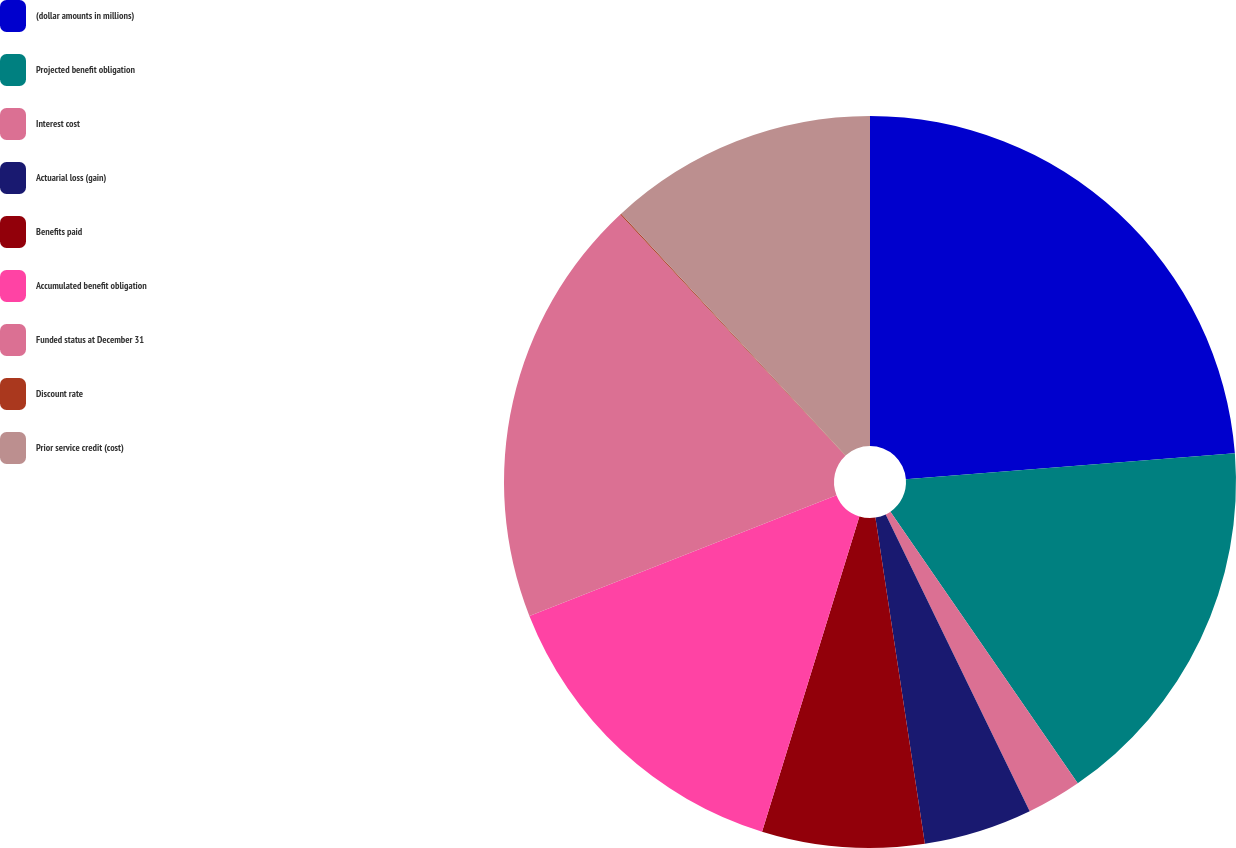<chart> <loc_0><loc_0><loc_500><loc_500><pie_chart><fcel>(dollar amounts in millions)<fcel>Projected benefit obligation<fcel>Interest cost<fcel>Actuarial loss (gain)<fcel>Benefits paid<fcel>Accumulated benefit obligation<fcel>Funded status at December 31<fcel>Discount rate<fcel>Prior service credit (cost)<nl><fcel>23.75%<fcel>16.64%<fcel>2.42%<fcel>4.79%<fcel>7.16%<fcel>14.27%<fcel>19.01%<fcel>0.05%<fcel>11.9%<nl></chart> 